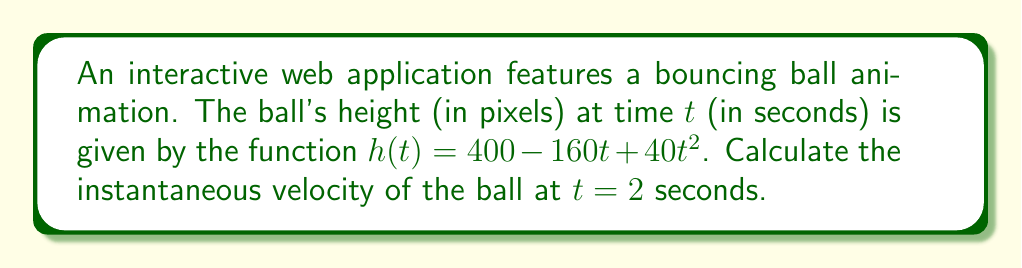What is the answer to this math problem? To find the instantaneous velocity of the ball at $t = 2$ seconds, we need to calculate the derivative of the height function $h(t)$ and evaluate it at $t = 2$.

Step 1: Find the derivative of $h(t)$.
$$h(t) = 400 - 160t + 40t^2$$
$$h'(t) = -160 + 80t$$

The derivative $h'(t)$ represents the velocity function of the ball.

Step 2: Evaluate the derivative at $t = 2$.
$$h'(2) = -160 + 80(2)$$
$$h'(2) = -160 + 160$$
$$h'(2) = 0$$

Therefore, the instantaneous velocity of the ball at $t = 2$ seconds is 0 pixels per second.

This result indicates that at $t = 2$ seconds, the ball momentarily comes to rest, which likely represents the highest point of its bounce in the animation sequence.
Answer: 0 pixels/second 